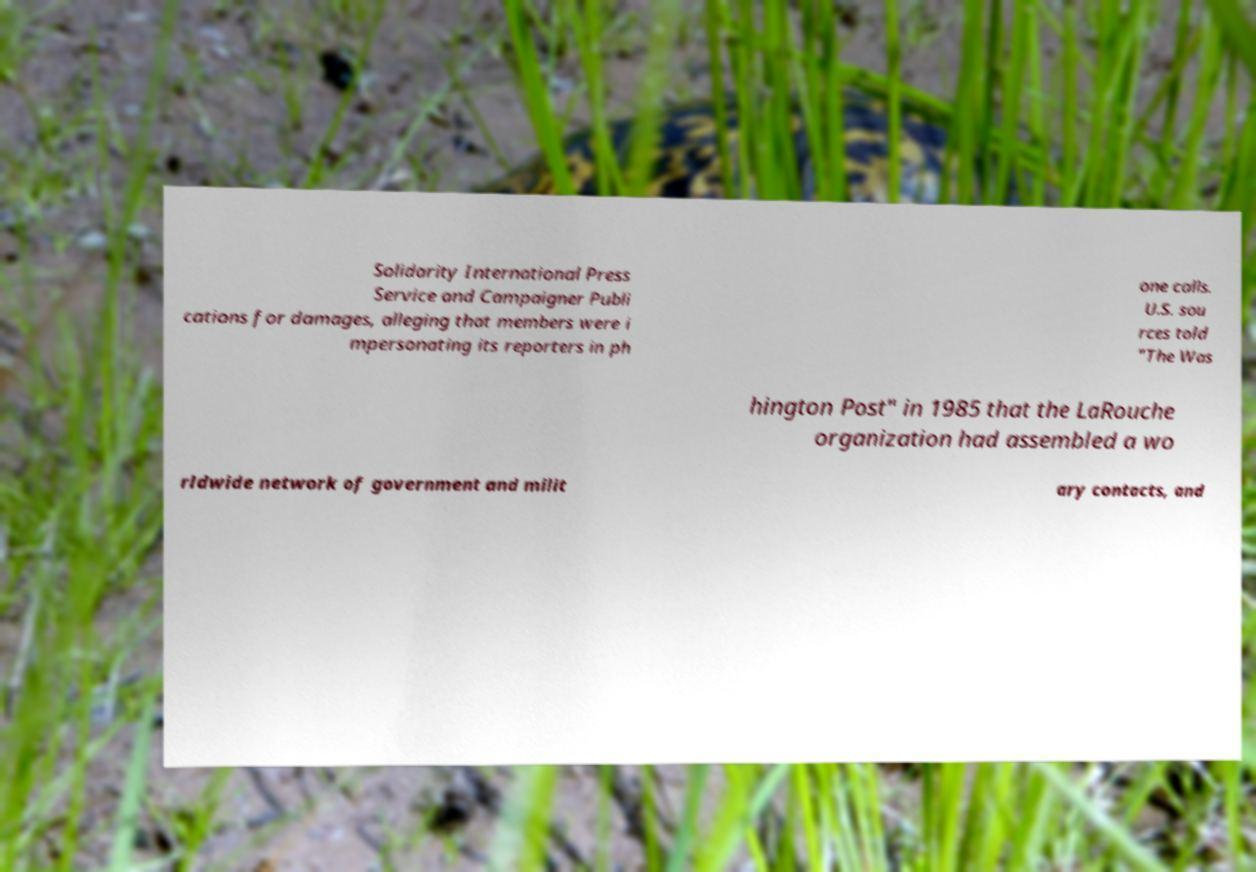I need the written content from this picture converted into text. Can you do that? Solidarity International Press Service and Campaigner Publi cations for damages, alleging that members were i mpersonating its reporters in ph one calls. U.S. sou rces told "The Was hington Post" in 1985 that the LaRouche organization had assembled a wo rldwide network of government and milit ary contacts, and 